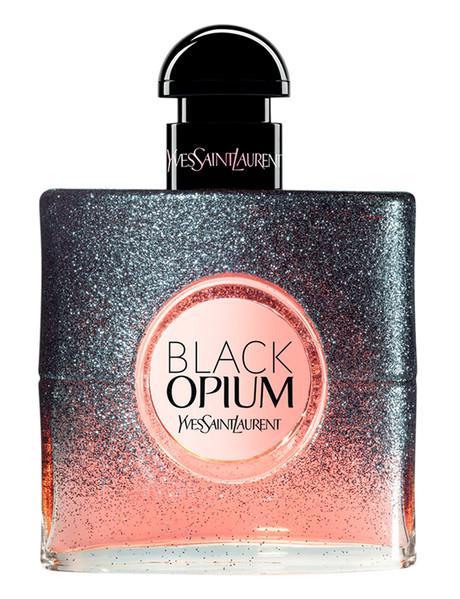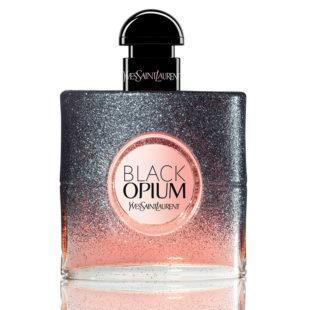The first image is the image on the left, the second image is the image on the right. Examine the images to the left and right. Is the description "No single image contains more than one fragrance bottle, and the bottles on the left and right are at least very similar in size, shape, and color." accurate? Answer yes or no. Yes. 